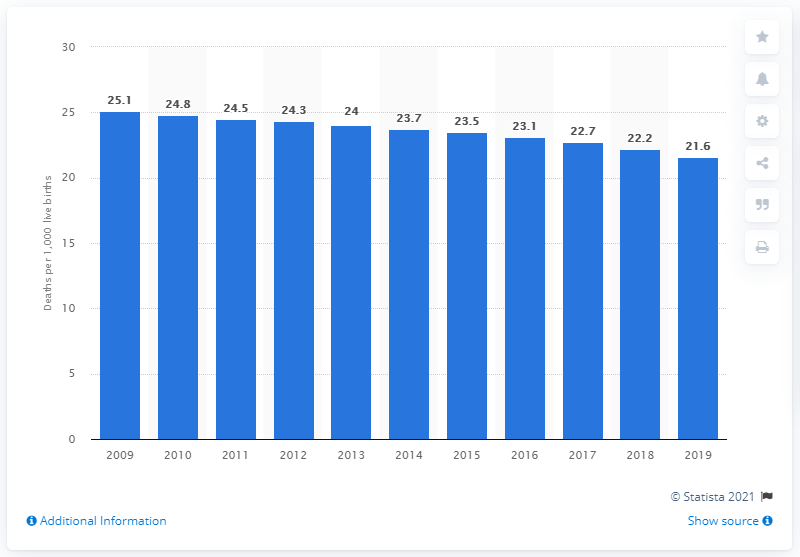Outline some significant characteristics in this image. The infant mortality rate in the Philippines in 2019 was 21.6 deaths per 1,000 live births, according to recent data. 